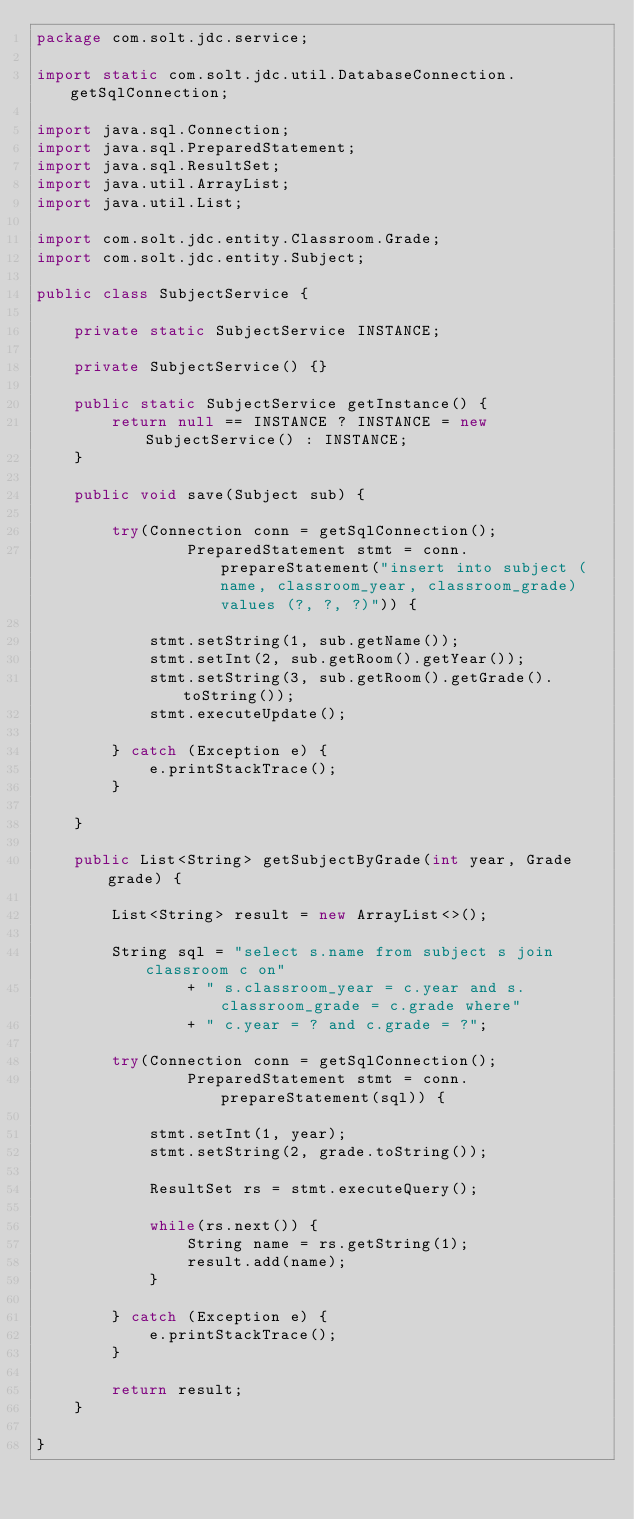Convert code to text. <code><loc_0><loc_0><loc_500><loc_500><_Java_>package com.solt.jdc.service;

import static com.solt.jdc.util.DatabaseConnection.getSqlConnection;

import java.sql.Connection;
import java.sql.PreparedStatement;
import java.sql.ResultSet;
import java.util.ArrayList;
import java.util.List;

import com.solt.jdc.entity.Classroom.Grade;
import com.solt.jdc.entity.Subject;

public class SubjectService {
	
	private static SubjectService INSTANCE;
	
	private SubjectService() {}
	
	public static SubjectService getInstance() {
		return null == INSTANCE ? INSTANCE = new SubjectService() : INSTANCE;
	}
	
	public void save(Subject sub) {
		
		try(Connection conn = getSqlConnection();
				PreparedStatement stmt = conn.prepareStatement("insert into subject (name, classroom_year, classroom_grade) values (?, ?, ?)")) {
			
			stmt.setString(1, sub.getName());
			stmt.setInt(2, sub.getRoom().getYear());
			stmt.setString(3, sub.getRoom().getGrade().toString());
			stmt.executeUpdate();
			
		} catch (Exception e) {
			e.printStackTrace();
		}
		
	}
	
	public List<String> getSubjectByGrade(int year, Grade grade) {
		
		List<String> result = new ArrayList<>();
		
		String sql = "select s.name from subject s join classroom c on"
				+ " s.classroom_year = c.year and s.classroom_grade = c.grade where"
				+ " c.year = ? and c.grade = ?";
		
		try(Connection conn = getSqlConnection();
				PreparedStatement stmt = conn.prepareStatement(sql)) {
			
			stmt.setInt(1, year);
			stmt.setString(2, grade.toString());
			
			ResultSet rs = stmt.executeQuery();
			
			while(rs.next()) {
				String name = rs.getString(1);
				result.add(name);
			}
			
		} catch (Exception e) {
			e.printStackTrace();
		}
		
		return result;
	}

}
</code> 